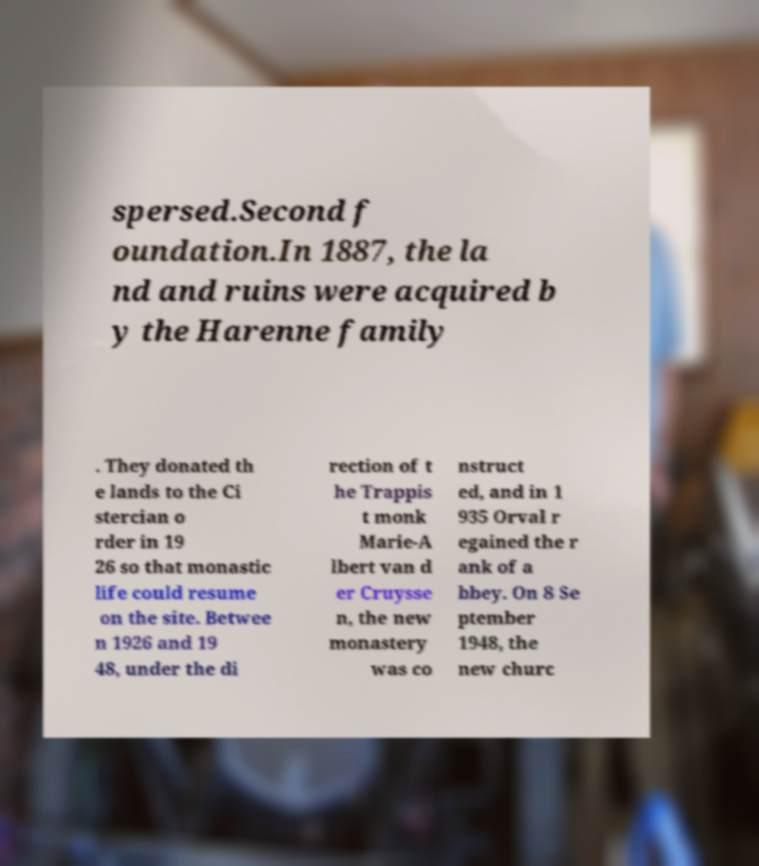Can you read and provide the text displayed in the image?This photo seems to have some interesting text. Can you extract and type it out for me? spersed.Second f oundation.In 1887, the la nd and ruins were acquired b y the Harenne family . They donated th e lands to the Ci stercian o rder in 19 26 so that monastic life could resume on the site. Betwee n 1926 and 19 48, under the di rection of t he Trappis t monk Marie-A lbert van d er Cruysse n, the new monastery was co nstruct ed, and in 1 935 Orval r egained the r ank of a bbey. On 8 Se ptember 1948, the new churc 